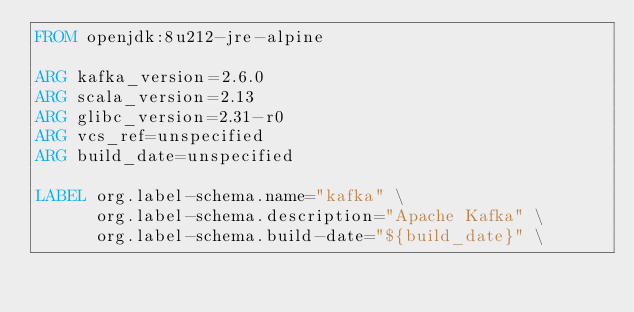Convert code to text. <code><loc_0><loc_0><loc_500><loc_500><_Dockerfile_>FROM openjdk:8u212-jre-alpine

ARG kafka_version=2.6.0
ARG scala_version=2.13
ARG glibc_version=2.31-r0
ARG vcs_ref=unspecified
ARG build_date=unspecified

LABEL org.label-schema.name="kafka" \
      org.label-schema.description="Apache Kafka" \
      org.label-schema.build-date="${build_date}" \</code> 